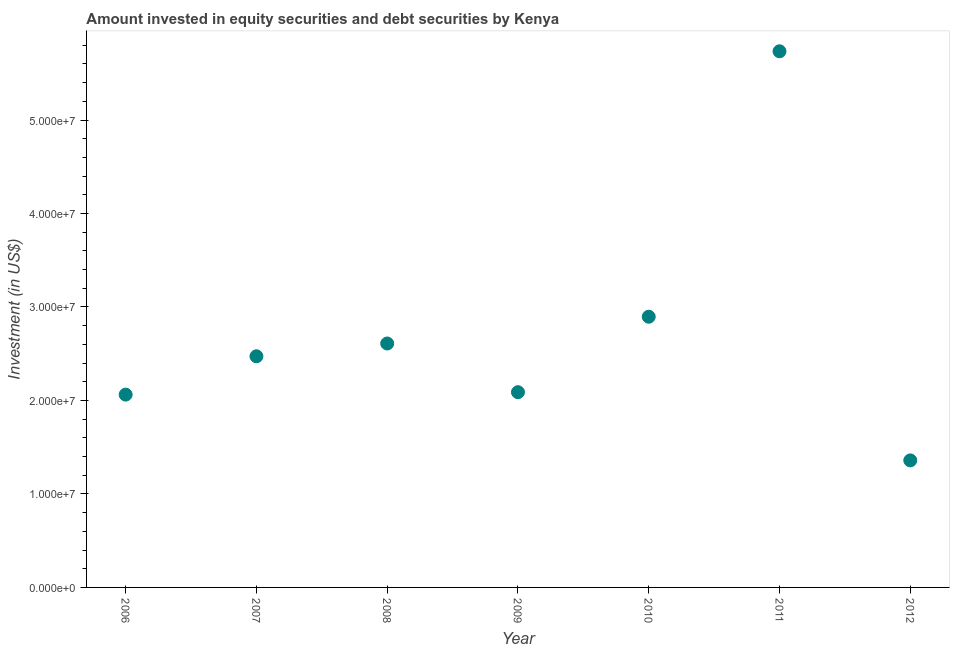What is the portfolio investment in 2007?
Keep it short and to the point. 2.47e+07. Across all years, what is the maximum portfolio investment?
Make the answer very short. 5.74e+07. Across all years, what is the minimum portfolio investment?
Make the answer very short. 1.36e+07. In which year was the portfolio investment maximum?
Provide a short and direct response. 2011. What is the sum of the portfolio investment?
Your answer should be very brief. 1.92e+08. What is the difference between the portfolio investment in 2007 and 2012?
Your answer should be very brief. 1.11e+07. What is the average portfolio investment per year?
Make the answer very short. 2.75e+07. What is the median portfolio investment?
Keep it short and to the point. 2.47e+07. In how many years, is the portfolio investment greater than 4000000 US$?
Your answer should be compact. 7. What is the ratio of the portfolio investment in 2006 to that in 2007?
Ensure brevity in your answer.  0.83. Is the portfolio investment in 2007 less than that in 2011?
Keep it short and to the point. Yes. Is the difference between the portfolio investment in 2006 and 2010 greater than the difference between any two years?
Keep it short and to the point. No. What is the difference between the highest and the second highest portfolio investment?
Offer a terse response. 2.84e+07. Is the sum of the portfolio investment in 2006 and 2007 greater than the maximum portfolio investment across all years?
Offer a terse response. No. What is the difference between the highest and the lowest portfolio investment?
Provide a succinct answer. 4.38e+07. How many years are there in the graph?
Give a very brief answer. 7. What is the difference between two consecutive major ticks on the Y-axis?
Your response must be concise. 1.00e+07. Does the graph contain any zero values?
Offer a very short reply. No. What is the title of the graph?
Provide a succinct answer. Amount invested in equity securities and debt securities by Kenya. What is the label or title of the Y-axis?
Your answer should be compact. Investment (in US$). What is the Investment (in US$) in 2006?
Give a very brief answer. 2.06e+07. What is the Investment (in US$) in 2007?
Give a very brief answer. 2.47e+07. What is the Investment (in US$) in 2008?
Provide a short and direct response. 2.61e+07. What is the Investment (in US$) in 2009?
Your answer should be very brief. 2.09e+07. What is the Investment (in US$) in 2010?
Your response must be concise. 2.90e+07. What is the Investment (in US$) in 2011?
Keep it short and to the point. 5.74e+07. What is the Investment (in US$) in 2012?
Provide a short and direct response. 1.36e+07. What is the difference between the Investment (in US$) in 2006 and 2007?
Your answer should be compact. -4.10e+06. What is the difference between the Investment (in US$) in 2006 and 2008?
Make the answer very short. -5.47e+06. What is the difference between the Investment (in US$) in 2006 and 2009?
Provide a succinct answer. -2.59e+05. What is the difference between the Investment (in US$) in 2006 and 2010?
Provide a short and direct response. -8.33e+06. What is the difference between the Investment (in US$) in 2006 and 2011?
Offer a very short reply. -3.67e+07. What is the difference between the Investment (in US$) in 2006 and 2012?
Give a very brief answer. 7.04e+06. What is the difference between the Investment (in US$) in 2007 and 2008?
Your response must be concise. -1.37e+06. What is the difference between the Investment (in US$) in 2007 and 2009?
Ensure brevity in your answer.  3.84e+06. What is the difference between the Investment (in US$) in 2007 and 2010?
Give a very brief answer. -4.23e+06. What is the difference between the Investment (in US$) in 2007 and 2011?
Provide a short and direct response. -3.26e+07. What is the difference between the Investment (in US$) in 2007 and 2012?
Keep it short and to the point. 1.11e+07. What is the difference between the Investment (in US$) in 2008 and 2009?
Your answer should be compact. 5.21e+06. What is the difference between the Investment (in US$) in 2008 and 2010?
Make the answer very short. -2.86e+06. What is the difference between the Investment (in US$) in 2008 and 2011?
Give a very brief answer. -3.13e+07. What is the difference between the Investment (in US$) in 2008 and 2012?
Keep it short and to the point. 1.25e+07. What is the difference between the Investment (in US$) in 2009 and 2010?
Give a very brief answer. -8.07e+06. What is the difference between the Investment (in US$) in 2009 and 2011?
Provide a succinct answer. -3.65e+07. What is the difference between the Investment (in US$) in 2009 and 2012?
Give a very brief answer. 7.29e+06. What is the difference between the Investment (in US$) in 2010 and 2011?
Provide a succinct answer. -2.84e+07. What is the difference between the Investment (in US$) in 2010 and 2012?
Keep it short and to the point. 1.54e+07. What is the difference between the Investment (in US$) in 2011 and 2012?
Keep it short and to the point. 4.38e+07. What is the ratio of the Investment (in US$) in 2006 to that in 2007?
Your answer should be very brief. 0.83. What is the ratio of the Investment (in US$) in 2006 to that in 2008?
Provide a short and direct response. 0.79. What is the ratio of the Investment (in US$) in 2006 to that in 2010?
Offer a very short reply. 0.71. What is the ratio of the Investment (in US$) in 2006 to that in 2011?
Make the answer very short. 0.36. What is the ratio of the Investment (in US$) in 2006 to that in 2012?
Provide a succinct answer. 1.52. What is the ratio of the Investment (in US$) in 2007 to that in 2008?
Provide a succinct answer. 0.95. What is the ratio of the Investment (in US$) in 2007 to that in 2009?
Offer a terse response. 1.18. What is the ratio of the Investment (in US$) in 2007 to that in 2010?
Offer a very short reply. 0.85. What is the ratio of the Investment (in US$) in 2007 to that in 2011?
Offer a terse response. 0.43. What is the ratio of the Investment (in US$) in 2007 to that in 2012?
Make the answer very short. 1.82. What is the ratio of the Investment (in US$) in 2008 to that in 2009?
Offer a very short reply. 1.25. What is the ratio of the Investment (in US$) in 2008 to that in 2010?
Ensure brevity in your answer.  0.9. What is the ratio of the Investment (in US$) in 2008 to that in 2011?
Your answer should be compact. 0.46. What is the ratio of the Investment (in US$) in 2008 to that in 2012?
Provide a succinct answer. 1.92. What is the ratio of the Investment (in US$) in 2009 to that in 2010?
Make the answer very short. 0.72. What is the ratio of the Investment (in US$) in 2009 to that in 2011?
Keep it short and to the point. 0.36. What is the ratio of the Investment (in US$) in 2009 to that in 2012?
Your answer should be compact. 1.54. What is the ratio of the Investment (in US$) in 2010 to that in 2011?
Your answer should be compact. 0.51. What is the ratio of the Investment (in US$) in 2010 to that in 2012?
Offer a very short reply. 2.13. What is the ratio of the Investment (in US$) in 2011 to that in 2012?
Make the answer very short. 4.22. 